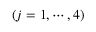Convert formula to latex. <formula><loc_0><loc_0><loc_500><loc_500>( j = 1 , \cdots , 4 )</formula> 